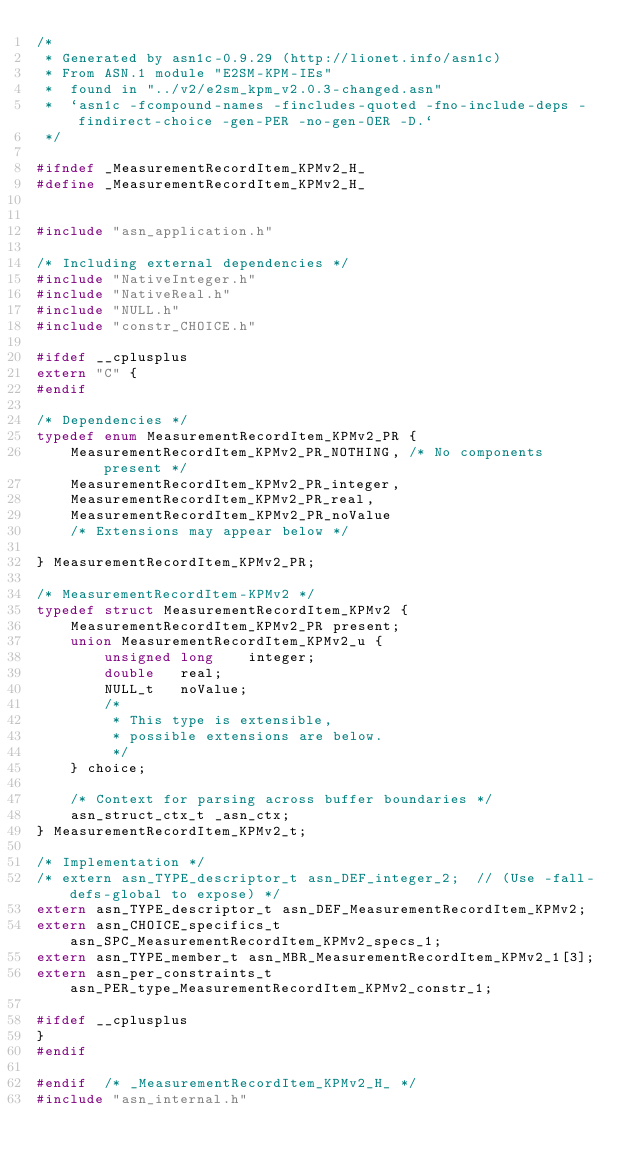Convert code to text. <code><loc_0><loc_0><loc_500><loc_500><_C_>/*
 * Generated by asn1c-0.9.29 (http://lionet.info/asn1c)
 * From ASN.1 module "E2SM-KPM-IEs"
 * 	found in "../v2/e2sm_kpm_v2.0.3-changed.asn"
 * 	`asn1c -fcompound-names -fincludes-quoted -fno-include-deps -findirect-choice -gen-PER -no-gen-OER -D.`
 */

#ifndef	_MeasurementRecordItem_KPMv2_H_
#define	_MeasurementRecordItem_KPMv2_H_


#include "asn_application.h"

/* Including external dependencies */
#include "NativeInteger.h"
#include "NativeReal.h"
#include "NULL.h"
#include "constr_CHOICE.h"

#ifdef __cplusplus
extern "C" {
#endif

/* Dependencies */
typedef enum MeasurementRecordItem_KPMv2_PR {
	MeasurementRecordItem_KPMv2_PR_NOTHING,	/* No components present */
	MeasurementRecordItem_KPMv2_PR_integer,
	MeasurementRecordItem_KPMv2_PR_real,
	MeasurementRecordItem_KPMv2_PR_noValue
	/* Extensions may appear below */
	
} MeasurementRecordItem_KPMv2_PR;

/* MeasurementRecordItem-KPMv2 */
typedef struct MeasurementRecordItem_KPMv2 {
	MeasurementRecordItem_KPMv2_PR present;
	union MeasurementRecordItem_KPMv2_u {
		unsigned long	 integer;
		double	 real;
		NULL_t	 noValue;
		/*
		 * This type is extensible,
		 * possible extensions are below.
		 */
	} choice;
	
	/* Context for parsing across buffer boundaries */
	asn_struct_ctx_t _asn_ctx;
} MeasurementRecordItem_KPMv2_t;

/* Implementation */
/* extern asn_TYPE_descriptor_t asn_DEF_integer_2;	// (Use -fall-defs-global to expose) */
extern asn_TYPE_descriptor_t asn_DEF_MeasurementRecordItem_KPMv2;
extern asn_CHOICE_specifics_t asn_SPC_MeasurementRecordItem_KPMv2_specs_1;
extern asn_TYPE_member_t asn_MBR_MeasurementRecordItem_KPMv2_1[3];
extern asn_per_constraints_t asn_PER_type_MeasurementRecordItem_KPMv2_constr_1;

#ifdef __cplusplus
}
#endif

#endif	/* _MeasurementRecordItem_KPMv2_H_ */
#include "asn_internal.h"
</code> 